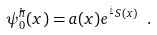Convert formula to latex. <formula><loc_0><loc_0><loc_500><loc_500>\psi ^ { \hbar } _ { 0 } ( x ) = a ( x ) e ^ { \frac { i } { } S ( x ) } \ .</formula> 